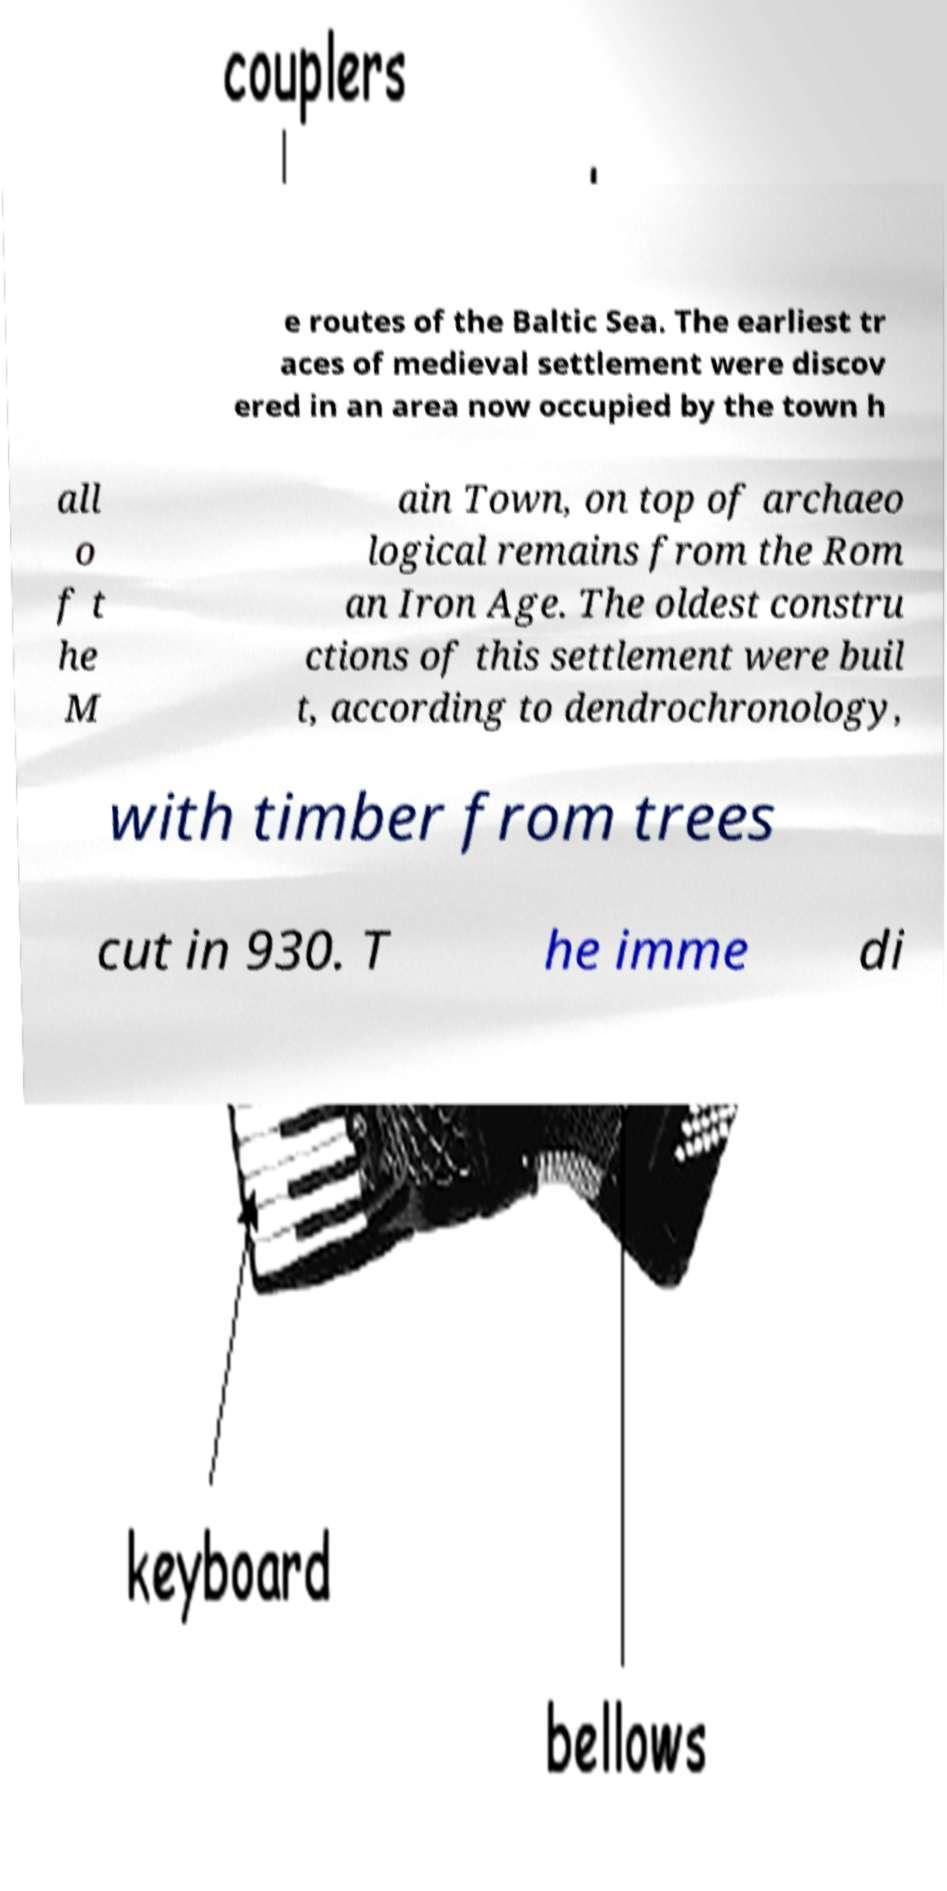For documentation purposes, I need the text within this image transcribed. Could you provide that? e routes of the Baltic Sea. The earliest tr aces of medieval settlement were discov ered in an area now occupied by the town h all o f t he M ain Town, on top of archaeo logical remains from the Rom an Iron Age. The oldest constru ctions of this settlement were buil t, according to dendrochronology, with timber from trees cut in 930. T he imme di 